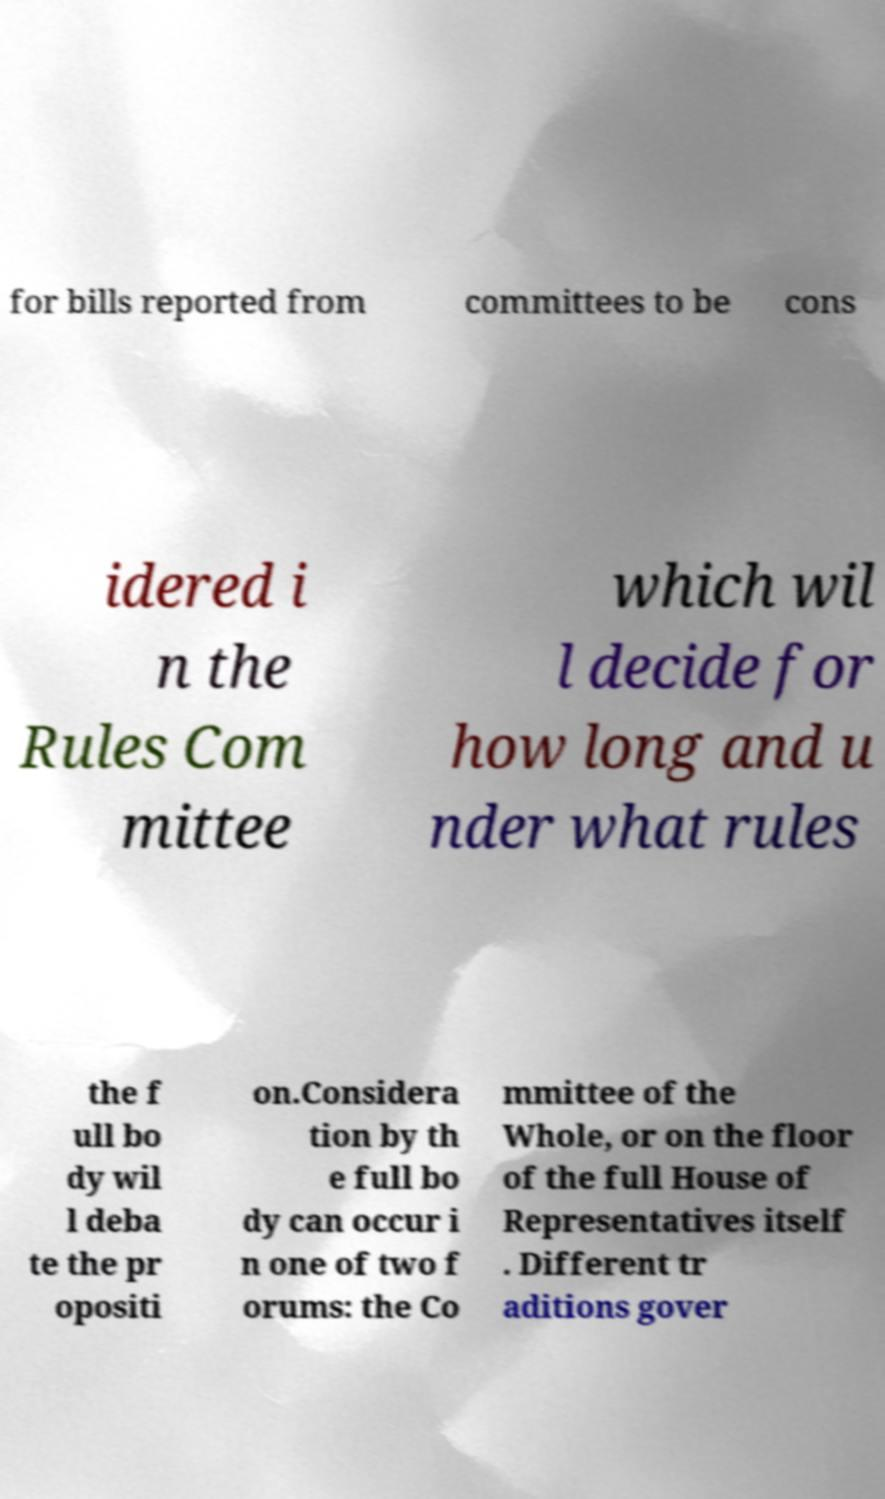Please read and relay the text visible in this image. What does it say? for bills reported from committees to be cons idered i n the Rules Com mittee which wil l decide for how long and u nder what rules the f ull bo dy wil l deba te the pr opositi on.Considera tion by th e full bo dy can occur i n one of two f orums: the Co mmittee of the Whole, or on the floor of the full House of Representatives itself . Different tr aditions gover 